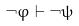<formula> <loc_0><loc_0><loc_500><loc_500>\neg \varphi \vdash \neg \psi</formula> 